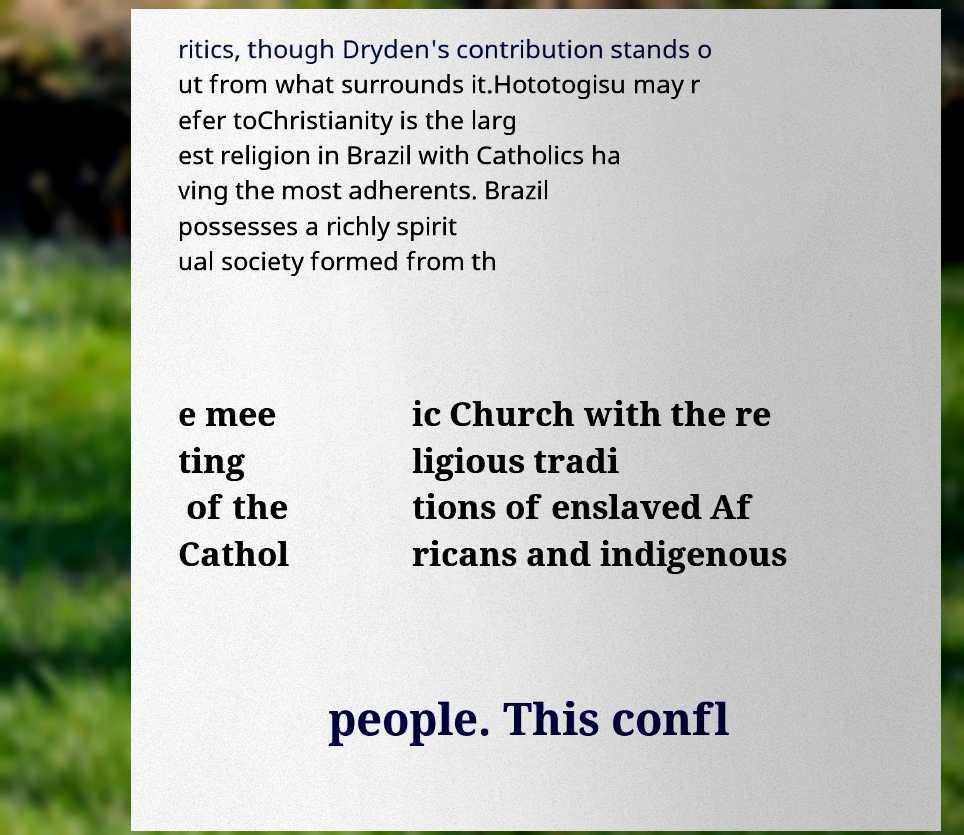What messages or text are displayed in this image? I need them in a readable, typed format. ritics, though Dryden's contribution stands o ut from what surrounds it.Hototogisu may r efer toChristianity is the larg est religion in Brazil with Catholics ha ving the most adherents. Brazil possesses a richly spirit ual society formed from th e mee ting of the Cathol ic Church with the re ligious tradi tions of enslaved Af ricans and indigenous people. This confl 